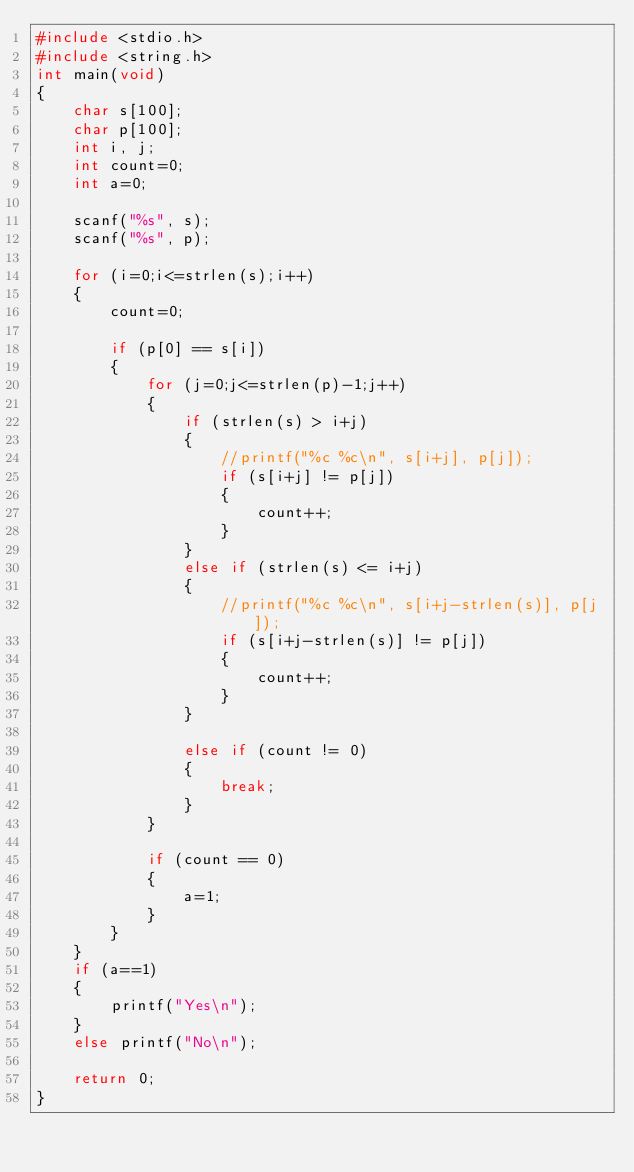<code> <loc_0><loc_0><loc_500><loc_500><_C_>#include <stdio.h>
#include <string.h>
int main(void)
{
	char s[100];
	char p[100];
	int i, j;
	int count=0;
	int a=0;

	scanf("%s", s);
	scanf("%s", p);

	for (i=0;i<=strlen(s);i++)
	{
		count=0;

		if (p[0] == s[i])
		{
			for (j=0;j<=strlen(p)-1;j++)
			{
				if (strlen(s) > i+j)
				{
					//printf("%c %c\n", s[i+j], p[j]);
					if (s[i+j] != p[j])
					{
						count++;
					}
				}
				else if (strlen(s) <= i+j)
				{
					//printf("%c %c\n", s[i+j-strlen(s)], p[j]);
					if (s[i+j-strlen(s)] != p[j])
					{	
						count++;
					}
				}

				else if (count != 0)
				{
					break;
				}
			}

			if (count == 0)
			{
				a=1;
			}
		}
	}
	if (a==1)
	{
		printf("Yes\n");
	}
	else printf("No\n");

	return 0;
}</code> 